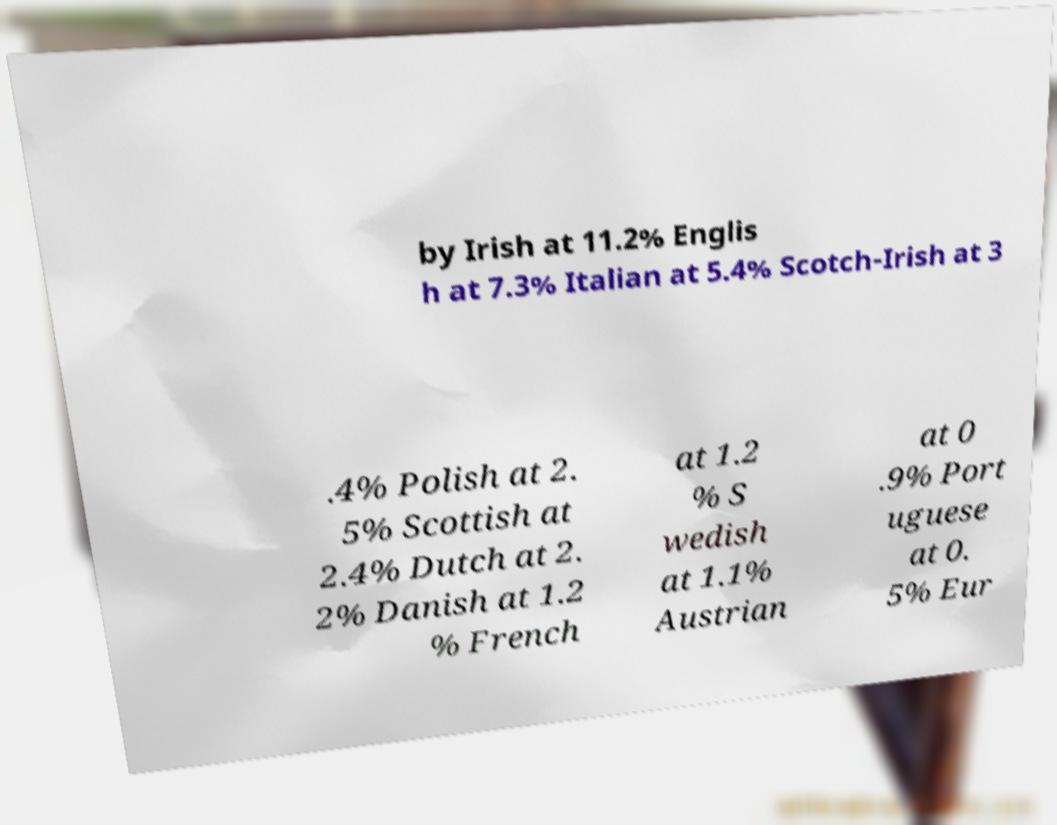Could you extract and type out the text from this image? by Irish at 11.2% Englis h at 7.3% Italian at 5.4% Scotch-Irish at 3 .4% Polish at 2. 5% Scottish at 2.4% Dutch at 2. 2% Danish at 1.2 % French at 1.2 % S wedish at 1.1% Austrian at 0 .9% Port uguese at 0. 5% Eur 